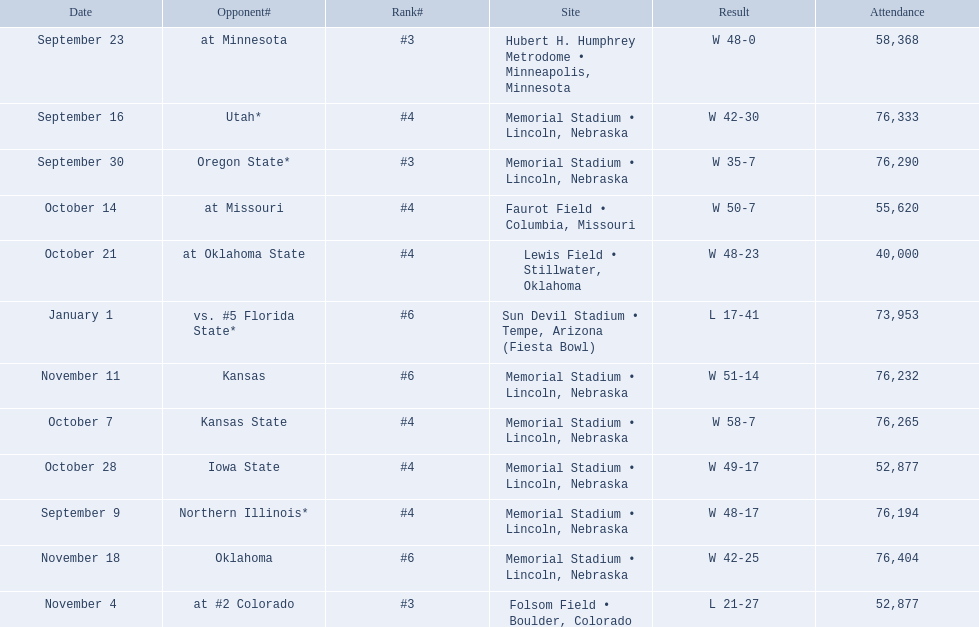When did nebraska play oregon state? September 30. What was the attendance at the september 30 game? 76,290. 